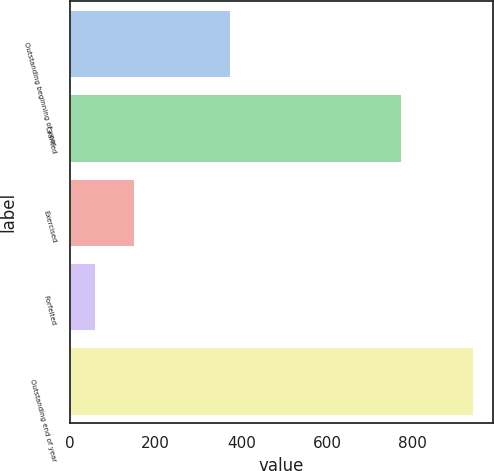Convert chart. <chart><loc_0><loc_0><loc_500><loc_500><bar_chart><fcel>Outstanding beginning of year<fcel>Granted<fcel>Exercised<fcel>Forfeited<fcel>Outstanding end of year<nl><fcel>374<fcel>774<fcel>150<fcel>58<fcel>940<nl></chart> 